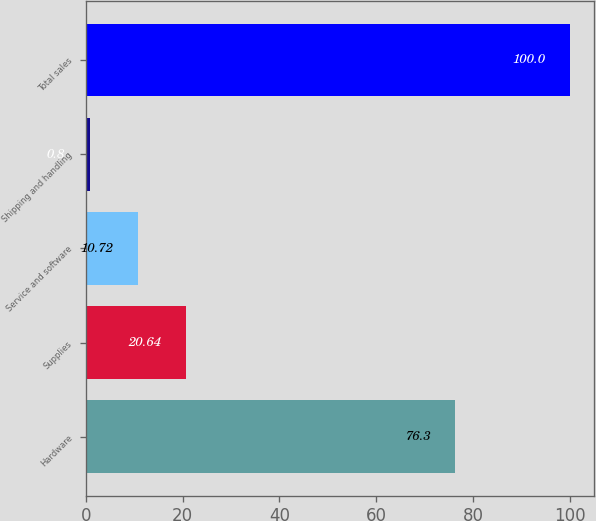<chart> <loc_0><loc_0><loc_500><loc_500><bar_chart><fcel>Hardware<fcel>Supplies<fcel>Service and software<fcel>Shipping and handling<fcel>Total sales<nl><fcel>76.3<fcel>20.64<fcel>10.72<fcel>0.8<fcel>100<nl></chart> 